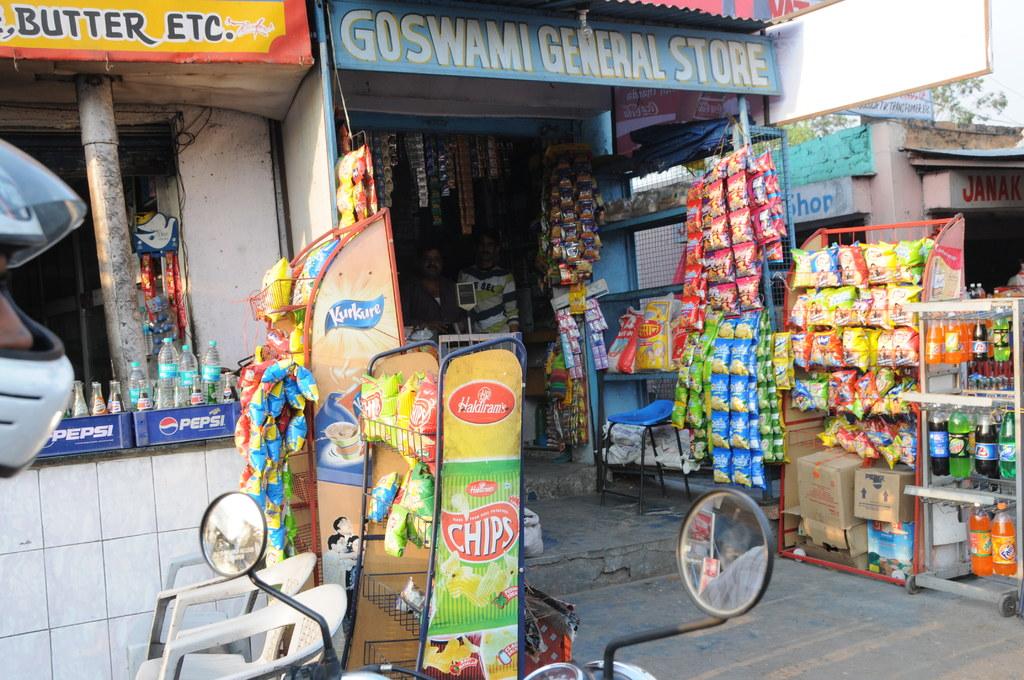What is the name of the general store?
Make the answer very short. Goswami. What soda brand is shown on the blue crate?
Give a very brief answer. Pepsi. 